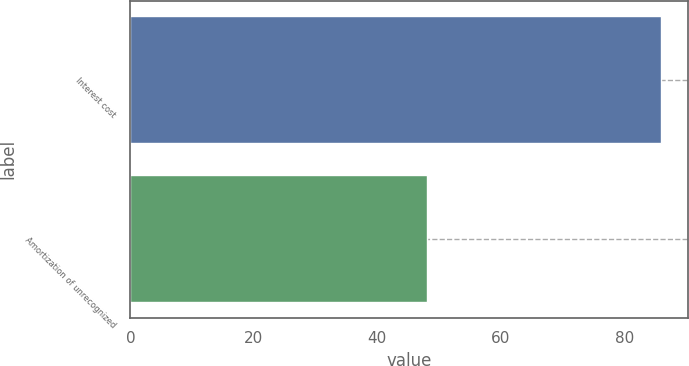Convert chart to OTSL. <chart><loc_0><loc_0><loc_500><loc_500><bar_chart><fcel>Interest cost<fcel>Amortization of unrecognized<nl><fcel>86<fcel>48<nl></chart> 